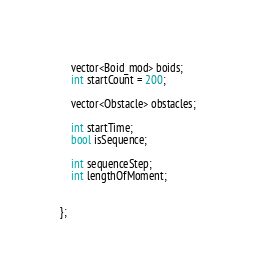<code> <loc_0><loc_0><loc_500><loc_500><_C_>	vector<Boid_mod> boids;
    int startCount = 200;
    
    vector<Obstacle> obstacles;
    
    int startTime;
    bool isSequence;
    
    int sequenceStep;
    int lengthOfMoment;
    
    
};
</code> 